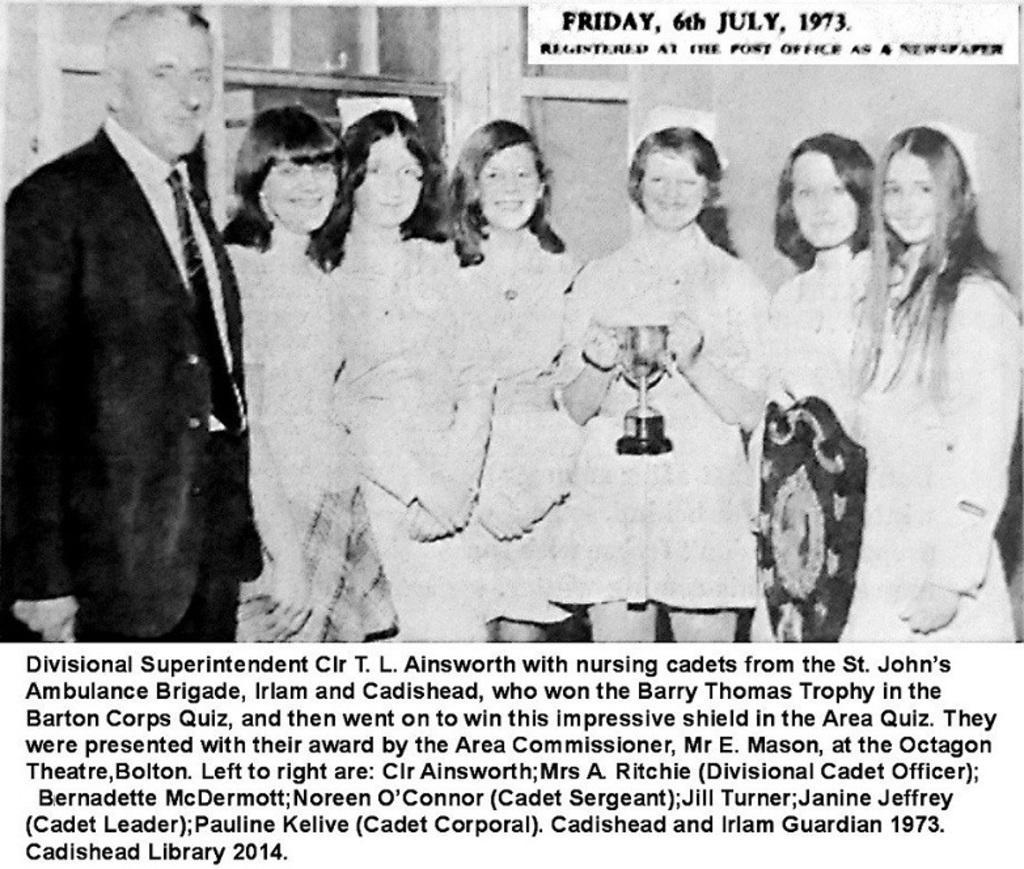How would you summarize this image in a sentence or two? This a poster where we can see persons standing and posing to a camera and on the bottom, there is some text. 